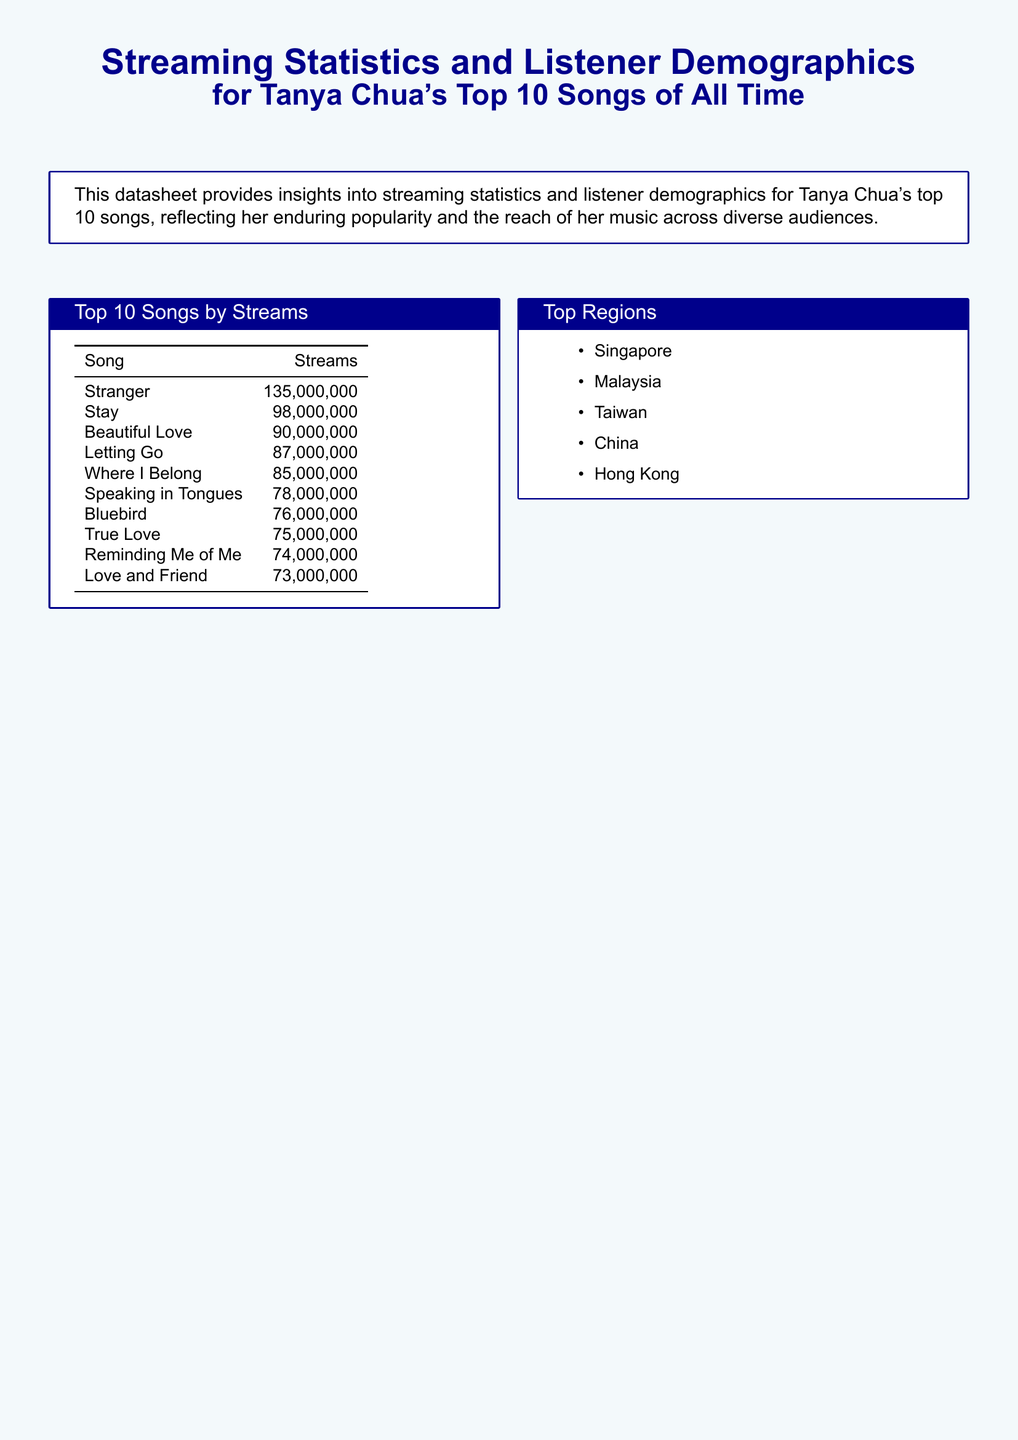What is the song with the highest number of streams? The song with the highest number of streams is listed at the top of the "Top 10 Songs by Streams" table, which is "Stranger" with 135 million streams.
Answer: Stranger How many streams does "Stay" have? "Stay" is listed in the "Top 10 Songs by Streams" table with 98 million streams.
Answer: 98,000,000 What percentage of listeners are aged 25-34? The "Average Age Distribution" table indicates that listeners aged 25-34 make up 41.7% of the audience.
Answer: 41.7% Which region is the top for Tanya Chua's listeners? The document lists Singapore as one of the top regions for Tanya Chua's listeners.
Answer: Singapore What is the gender distribution of listeners for "Beautiful Love"? The detailed song information table shows that the gender distribution for "Beautiful Love" is 42% male and 58% female.
Answer: M: 42%, F: 58% Which song has the lowest number of streams among the top 10? The song with the lowest number of streams in the "Top 10 Songs by Streams" table is "Love and Friend" with 73 million streams.
Answer: Love and Friend What is the average percentage of female listeners? The "Average Gender Distribution" table indicates that female listeners make up 54.3% of Tanya Chua's audience.
Answer: 54.3% Which age group has the highest percentage of listeners? The "Average Age Distribution" shows that the age group 25-34 has the highest percentage of listeners at 41.7%.
Answer: 25-34 